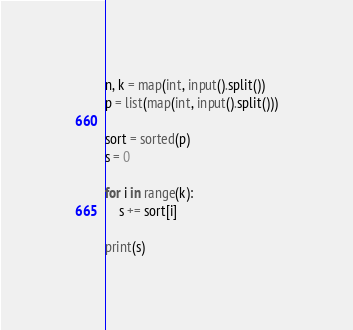Convert code to text. <code><loc_0><loc_0><loc_500><loc_500><_Python_>n, k = map(int, input().split())
p = list(map(int, input().split()))

sort = sorted(p)
s = 0

for i in range(k):
    s += sort[i]

print(s)
</code> 